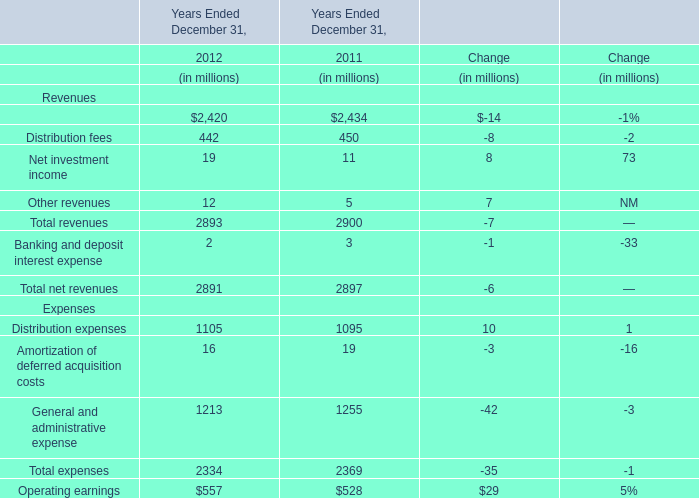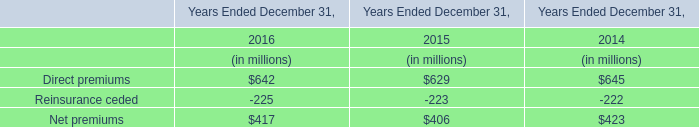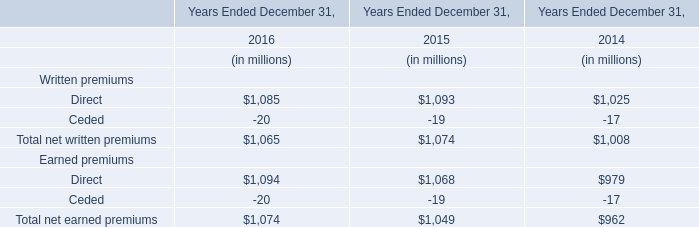What is the proportion of Distribution fees to Total revenues in 2012? 
Computations: (442 / 2893)
Answer: 0.15278. 